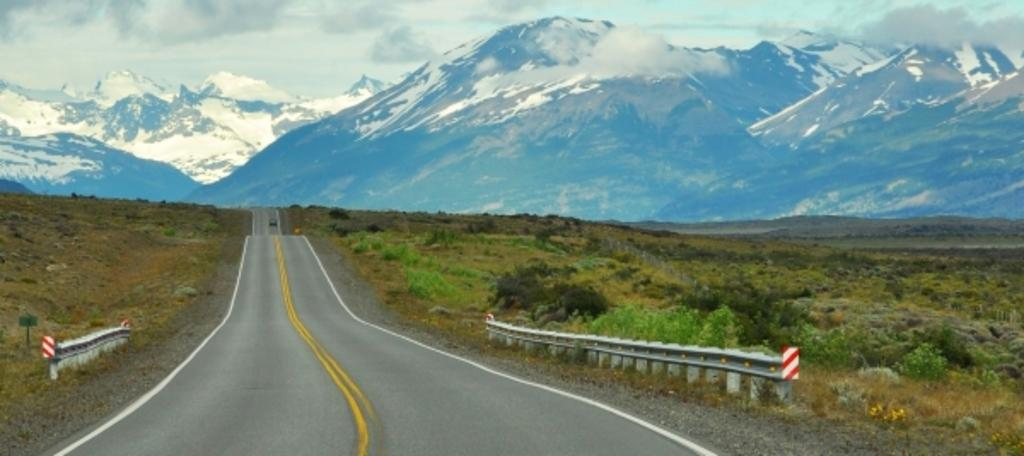What is the main feature in the center of the image? There is a road in the center of the image. What type of vegetation is present on both sides of the road? There is grass on both sides of the image. What can be seen in the distance in the background of the image? There are mountains with snow in the background of the image. What is visible above the mountains in the image? The sky is visible in the background of the image. What game is mom playing in the image? There is no game or mom present in the image; it features a road, grass, mountains, and the sky. What does the image smell like? The image does not have a smell, as it is a visual representation. 